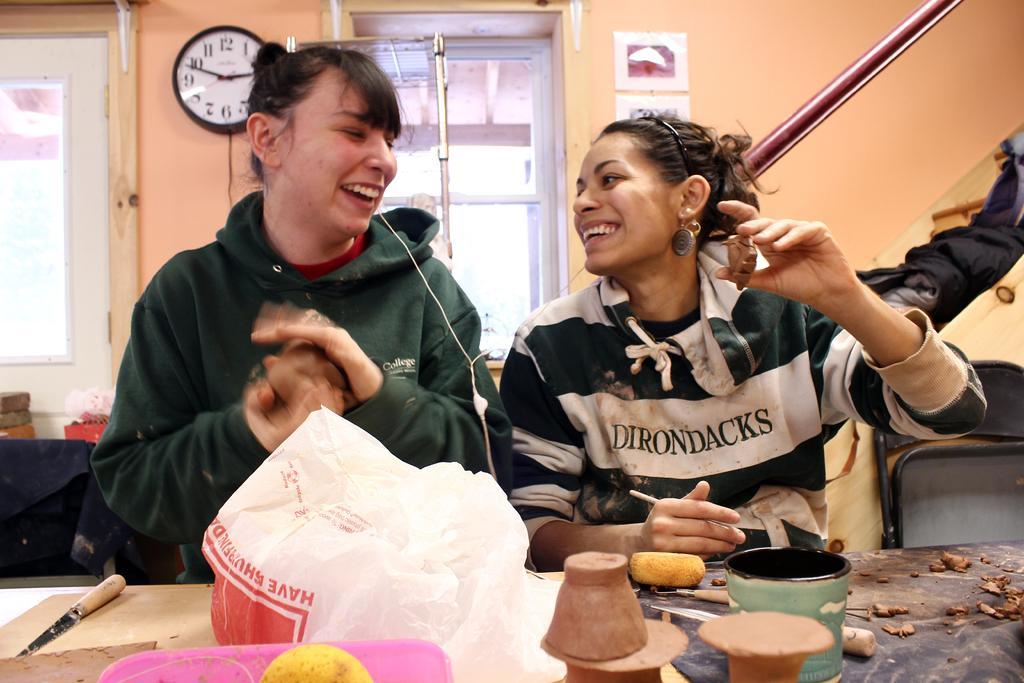How would you summarize this image in a sentence or two? In the center of the image there are two ladies. At the bottom of the image there is a table on which there are objects. In the background of the image there is a wall. There are windows. There is a clock. There is a poster. There are staircase. 